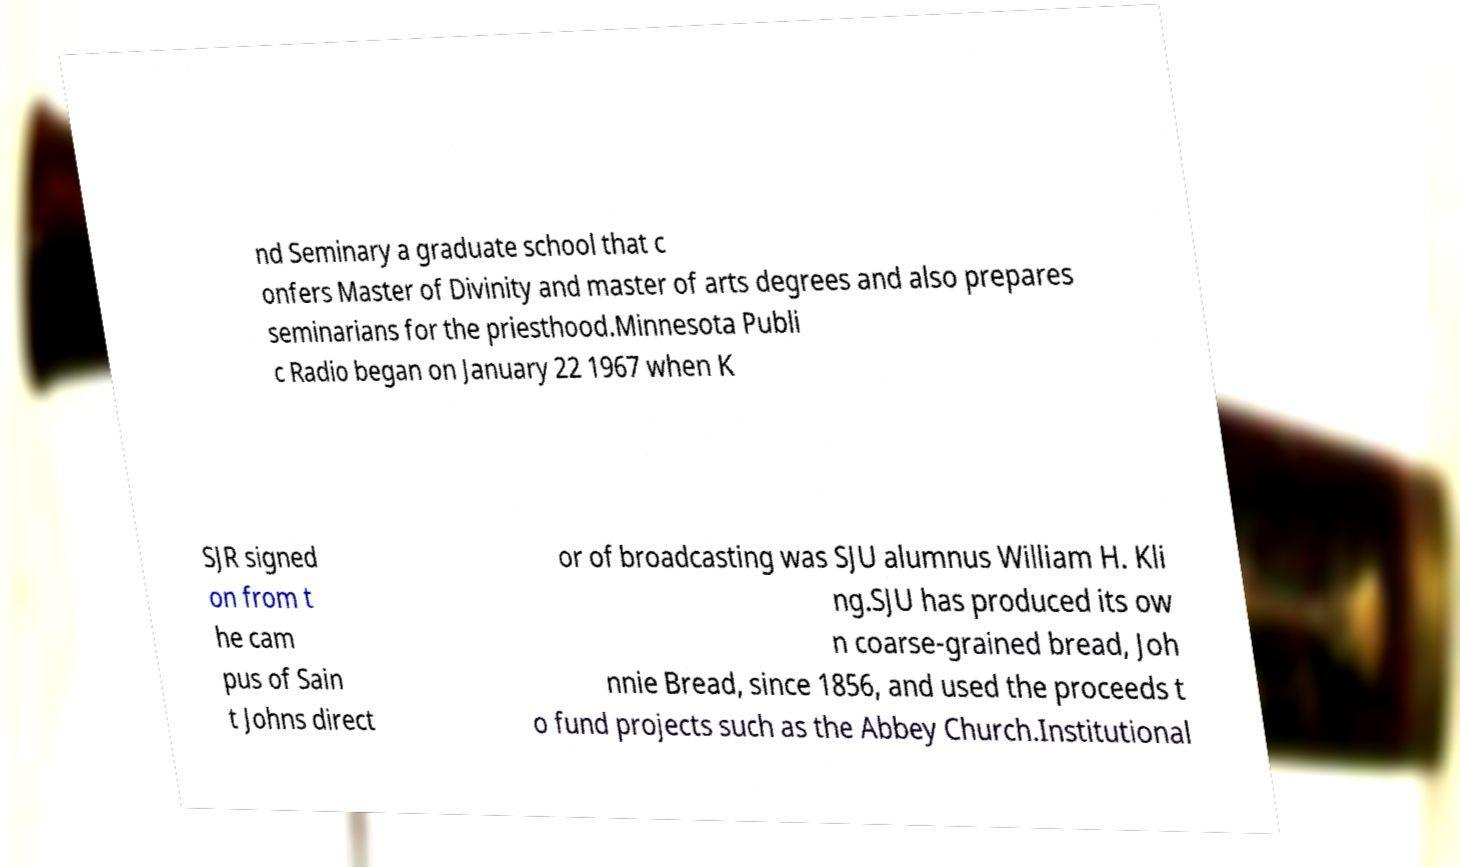Please read and relay the text visible in this image. What does it say? nd Seminary a graduate school that c onfers Master of Divinity and master of arts degrees and also prepares seminarians for the priesthood.Minnesota Publi c Radio began on January 22 1967 when K SJR signed on from t he cam pus of Sain t Johns direct or of broadcasting was SJU alumnus William H. Kli ng.SJU has produced its ow n coarse-grained bread, Joh nnie Bread, since 1856, and used the proceeds t o fund projects such as the Abbey Church.Institutional 